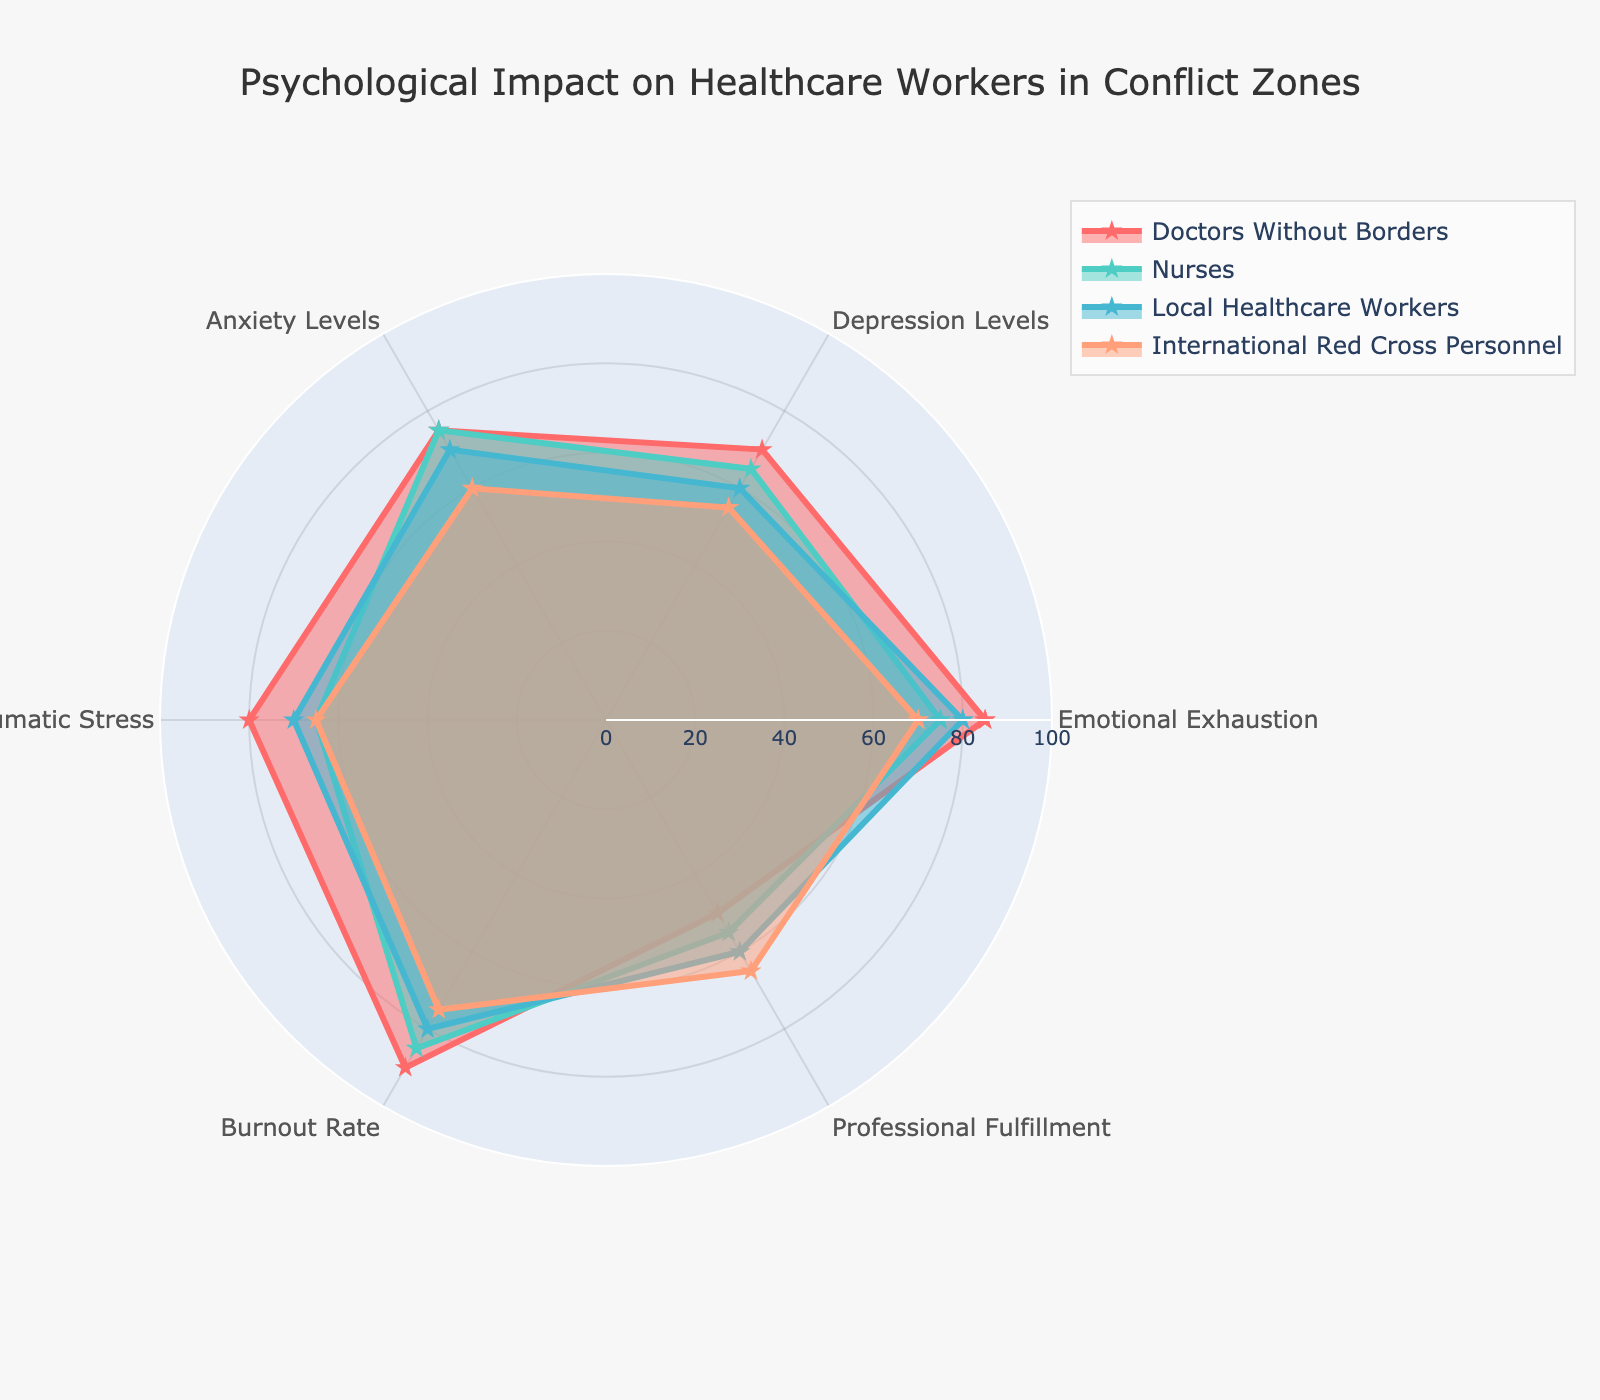what is the title of the figure? The title is usually found at the top of the figure and gives a brief description of the content. In this case, the title is clearly given as "Psychological Impact on Healthcare Workers in Conflict Zones".
Answer: Psychological Impact on Healthcare Workers in Conflict Zones which healthcare worker group has the highest Emotional Exhaustion level? By looking at the radial points for Emotional Exhaustion, the highest level is seen at the outermost part of the chart. Here, Doctors Without Borders reaches the furthest out, indicating the highest Emotional Exhaustion level.
Answer: Doctors Without Borders which category has the highest level of Post-Traumatic Stress? By observing the radial points for Post-Traumatic Stress across all groups, the highest point seems to be where the Doctors Without Borders group peaks, which is at 80.
Answer: Doctors Without Borders what is the average burnout rate across all groups? We sum the Burnout Rates for all groups (90+85+80+75) and then divide by the number of groups (4). The total sum is 330, and the average is 330/4 = 82.5.
Answer: 82.5 which group has the lowest professional fulfillment level? Reviewing the radial points for Professional Fulfillment, the lowest level is indicated by the inner point for Doctors Without Borders at 50.
Answer: Doctors Without Borders compare the depression levels for Nurses and International Red Cross Personnel. Which group shows higher levels? Looking at the radial points for Depression Levels, Nurses have a level of 65, while International Red Cross Personnel have 55. Therefore, Nurses have higher levels.
Answer: Nurses how do Anxiety Levels compare between Local Healthcare Workers and International Red Cross Personnel? The radial points for Anxiety Levels show that Local Healthcare Workers have a level of 70, whereas International Red Cross Personnel have a level of 60, indicating Local Healthcare Workers have higher Anxiety Levels.
Answer: Local Healthcare Workers what is the median value of Post-Traumatic Stress across all groups? The values for Post-Traumatic Stress are 80 (Doctors Without Borders), 65 (Nurses), 70 (Local Healthcare Workers), and 65 (International Red Cross Personnel). Arranging these (65, 65, 70, 80), the median is the average of the middle two values (65+70)/2 = 67.5.
Answer: 67.5 which group demonstrates the highest consistency in Anxiety Levels and Emotional Exhaustion? Looking at both Anxiety Levels and Emotional Exhaustion, the group with the most similar readings for these categories (75 each) is Nurses.
Answer: Nurses what is the difference between Emotional Exhaustion and Burnout Rate for Local Healthcare Workers? The value for Emotional Exhaustion is 80 and for Burnout Rate is 80. The difference is 80 - 80 = 10.
Answer: 10 